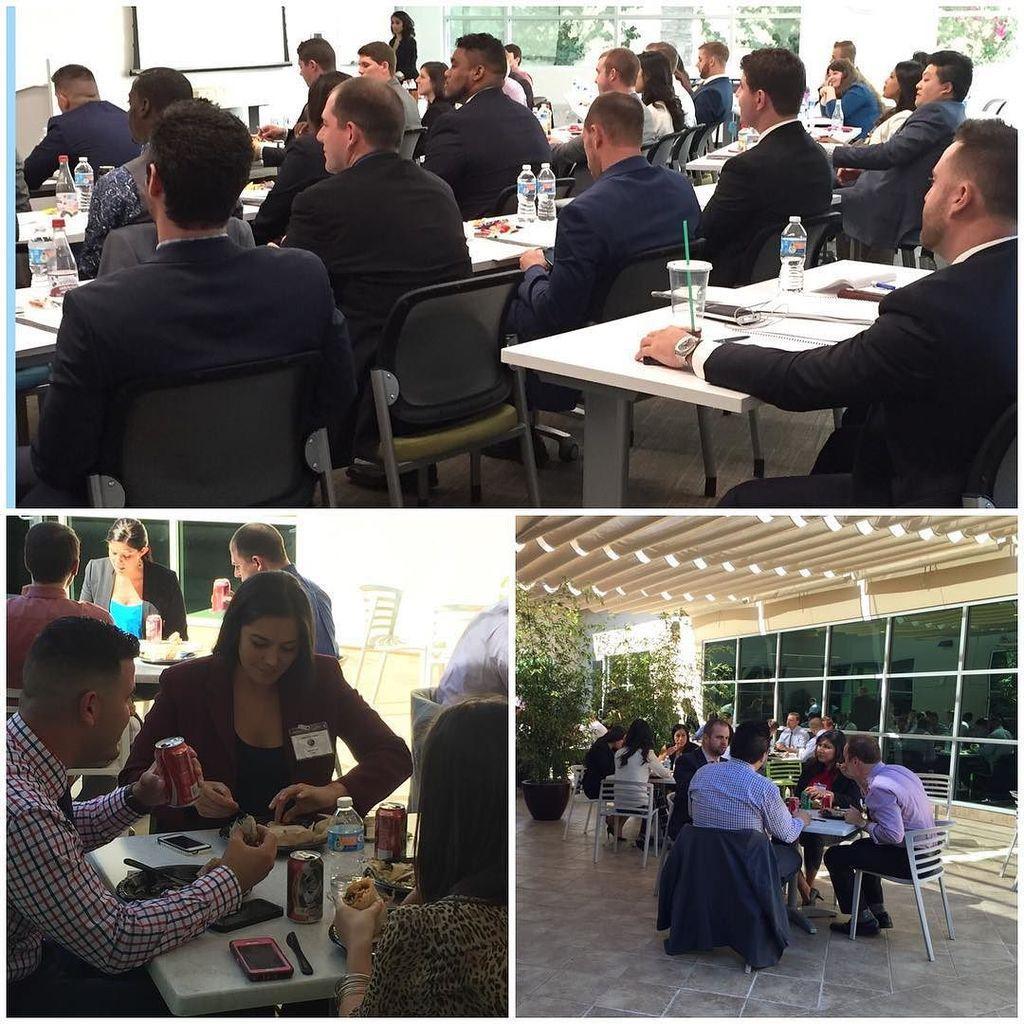How would you summarize this image in a sentence or two? In this image I can see collage photo where people are sitting on chairs. I can also see most of them are wearing blazers. Here I can see few tables and on these tables I can see food, cans, phones and bottles. 